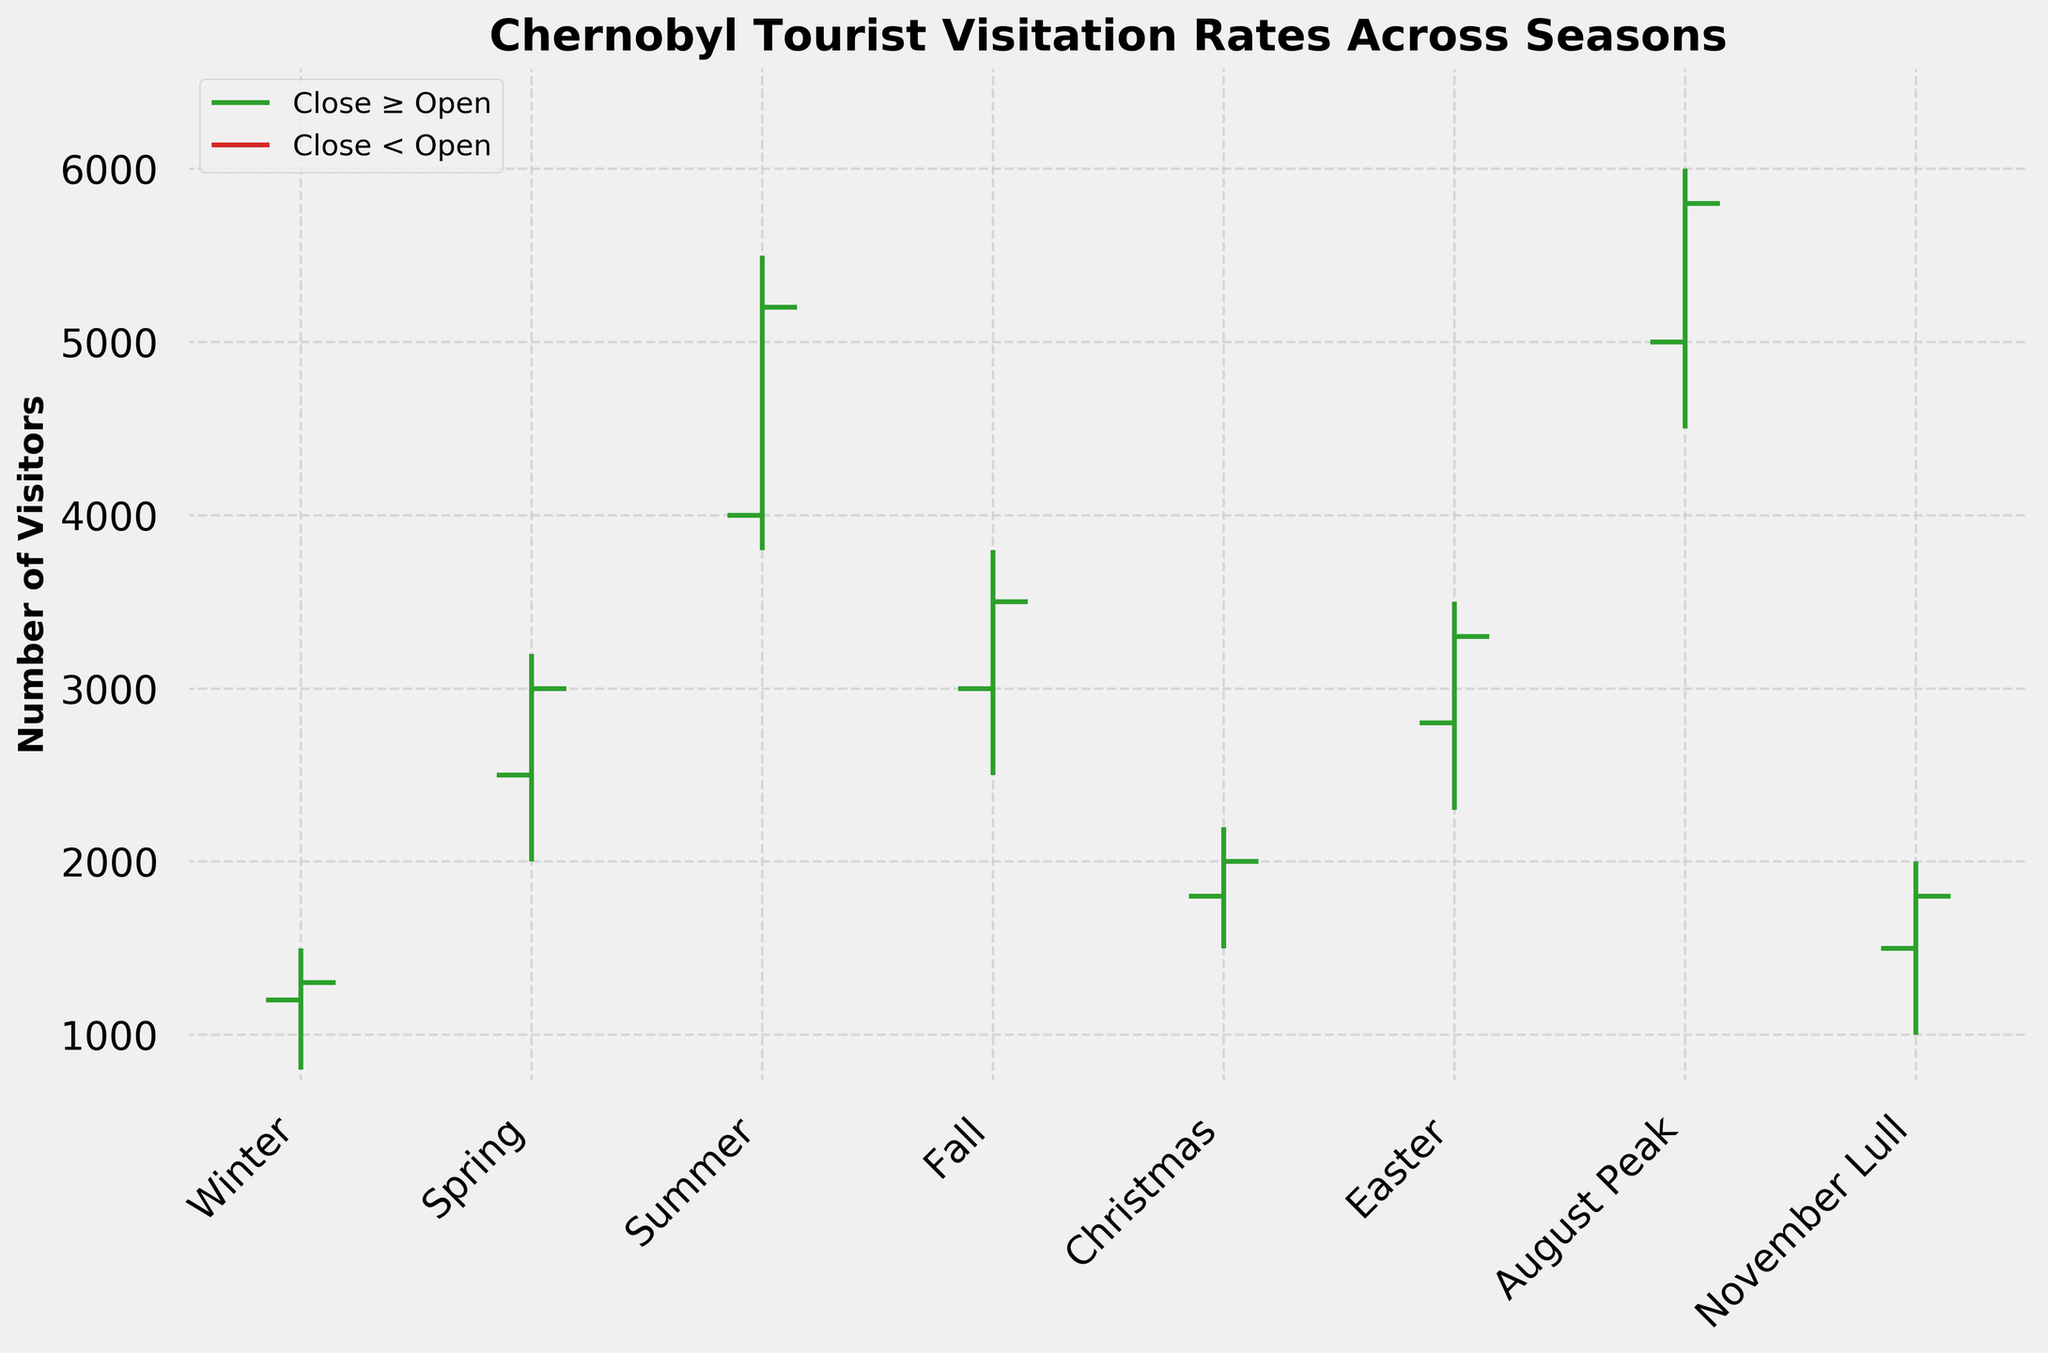Is summer the peak season for visitors to Chernobyl? The high value for summer is 5500, which is one of the highest points among all seasons. The only higher high value is in the August Peak with 6000. So, summer is one of the peak seasons.
Answer: Yes How do the visitation rates during Easter compare to those during Christmas? During Easter, the open, high, low, and close values are 2800, 3500, 2300, and 3300 respectively. For Christmas, these values are 1800, 2200, 1500, and 2000. Therefore, visitation rates during Easter are higher in all aspects compared to Christmas.
Answer: Easter is higher Which season had the lowest visitor turnout for the low value? The low value is the lowest in the Winter season which is 800.
Answer: Winter What’s the average number of visitors during the Fall season, based on the open and close values? The open and close values for Fall are 3000 and 3500 respectively. The average is calculated as (3000 + 3500) / 2 = 3250.
Answer: 3250 Did any season have visitation rates close higher than the opening values? If so, which ones? Seasons with close values higher than open values are Spring, Summer, Fall, Christmas, Easter, and August Peak.
Answer: Spring, Summer, Fall, Christmas, Easter, August Peak Between which periods is the difference between the high and low values most significant? The most significant difference between high and low values can be calculated as follows: 
- Winter: 1500 - 800 = 700
- Spring: 3200 - 2000 = 1200
- Summer: 5500 - 3800 = 1700
- Fall: 3800 - 2500 = 1300
- Christmas: 2200 - 1500 = 700
- Easter: 3500 - 2300 = 1200
- August Peak: 6000 - 4500 = 1500
- November Lull: 2000 - 1000 = 1000
The highest difference is in the Summer season (5500 - 3800 = 1700).
Answer: Summer What is the title of the figure? The title of the figure is "Chernobyl Tourist Visitation Rates Across Seasons."
Answer: Chernobyl Tourist Visitation Rates Across Seasons How does the number of visitors as per the close value in the Summer compare to that in the August Peak period? The close value for Summer is 5200 and for the August Peak is 5800. Therefore, the close value during the August Peak is higher than in Summer.
Answer: August Peak is higher What are the highest and lowest open values observed in the data? The highest open value is 5000 (August Peak) and the lowest open value is 1200 (Winter).
Answer: Highest: 5000, Lowest: 1200 Which season had an equal number of visitors for both its open and close values? There is no season where the open and close values are equal, as all seasons show a change between these values.
Answer: None 